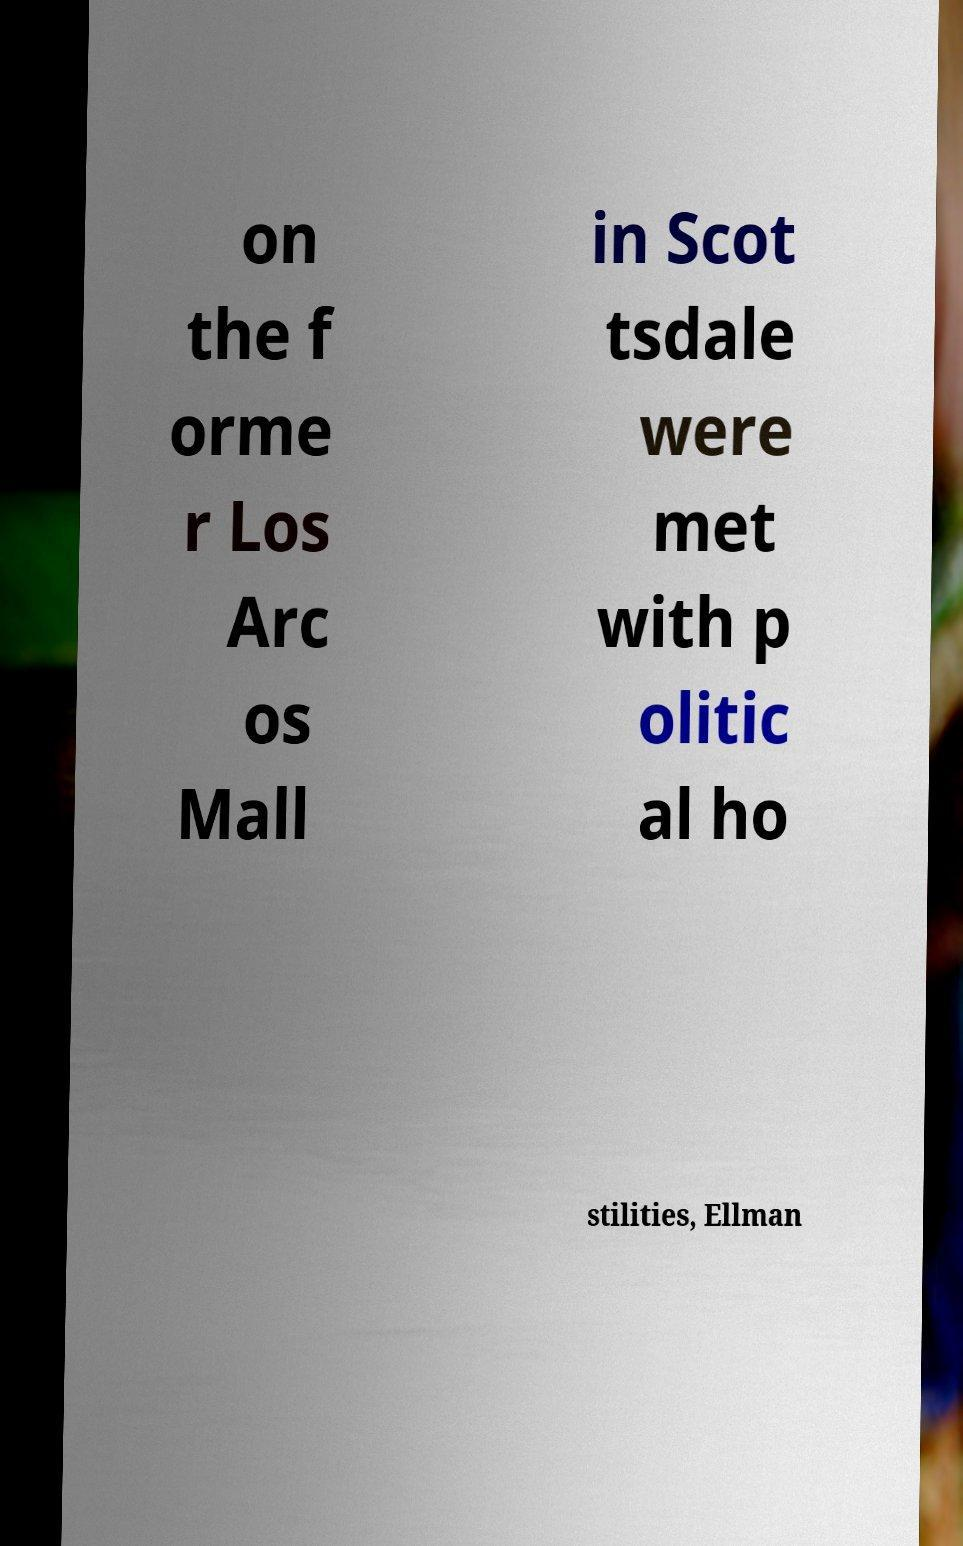Can you accurately transcribe the text from the provided image for me? on the f orme r Los Arc os Mall in Scot tsdale were met with p olitic al ho stilities, Ellman 